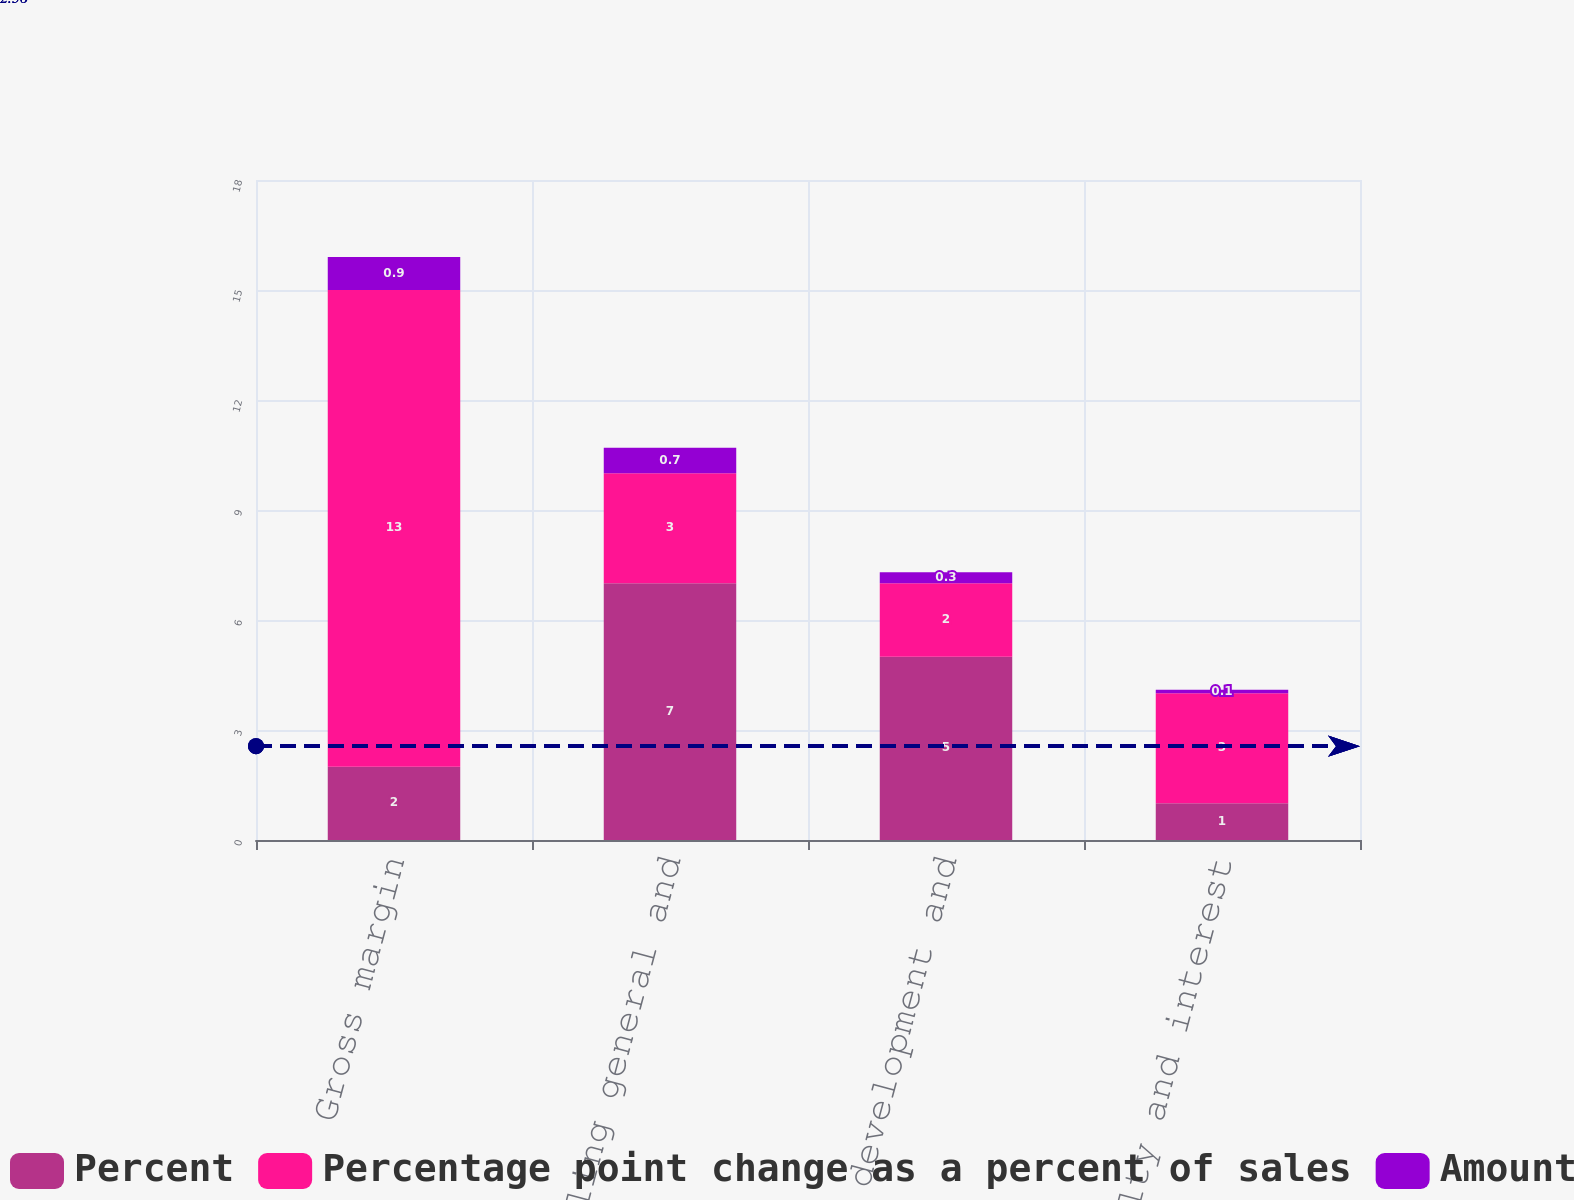<chart> <loc_0><loc_0><loc_500><loc_500><stacked_bar_chart><ecel><fcel>Gross margin<fcel>Selling general and<fcel>Research development and<fcel>Equity royalty and interest<nl><fcel>Percent<fcel>2<fcel>7<fcel>5<fcel>1<nl><fcel>Percentage point change as a percent of sales<fcel>13<fcel>3<fcel>2<fcel>3<nl><fcel>Amount<fcel>0.9<fcel>0.7<fcel>0.3<fcel>0.1<nl></chart> 